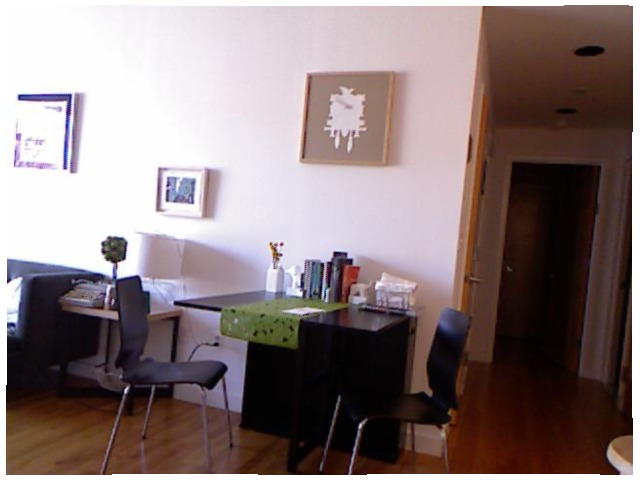<image>
Can you confirm if the tree is on the table? Yes. Looking at the image, I can see the tree is positioned on top of the table, with the table providing support. 